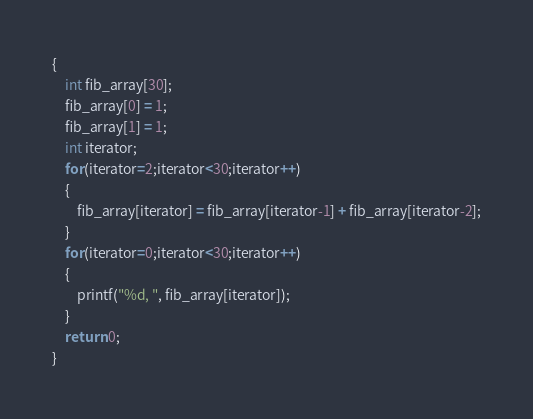Convert code to text. <code><loc_0><loc_0><loc_500><loc_500><_C_>{
    int fib_array[30];
    fib_array[0] = 1;
    fib_array[1] = 1;
    int iterator;
    for(iterator=2;iterator<30;iterator++)
    {
        fib_array[iterator] = fib_array[iterator-1] + fib_array[iterator-2];
    }
    for(iterator=0;iterator<30;iterator++)
    {
        printf("%d, ", fib_array[iterator]);
    }
    return 0;
}
</code> 